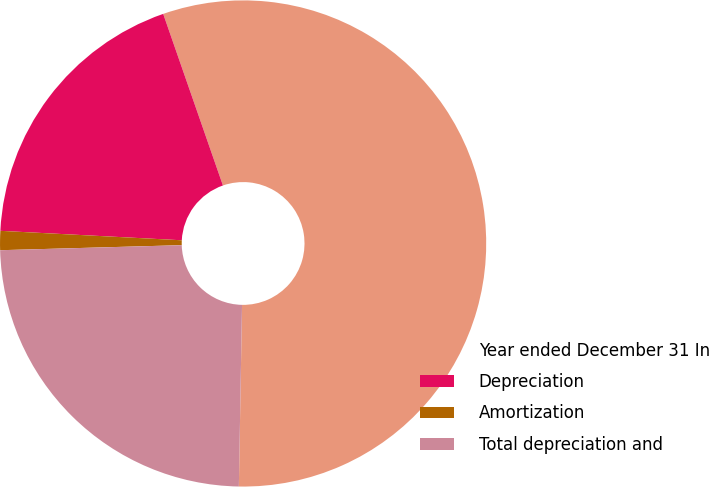Convert chart to OTSL. <chart><loc_0><loc_0><loc_500><loc_500><pie_chart><fcel>Year ended December 31 In<fcel>Depreciation<fcel>Amortization<fcel>Total depreciation and<nl><fcel>55.61%<fcel>18.84%<fcel>1.27%<fcel>24.28%<nl></chart> 